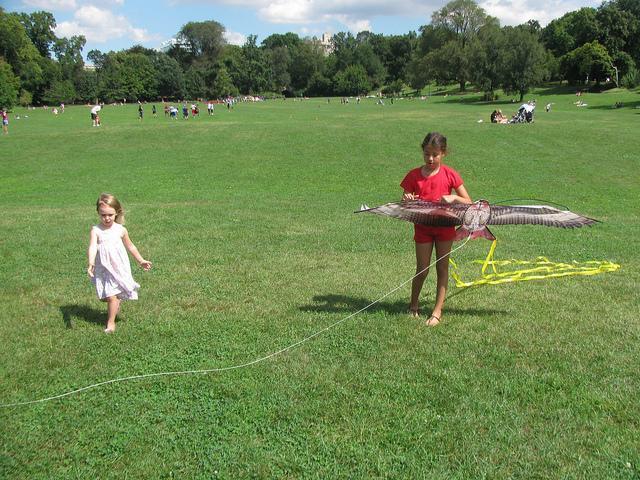How many people are there?
Give a very brief answer. 3. 